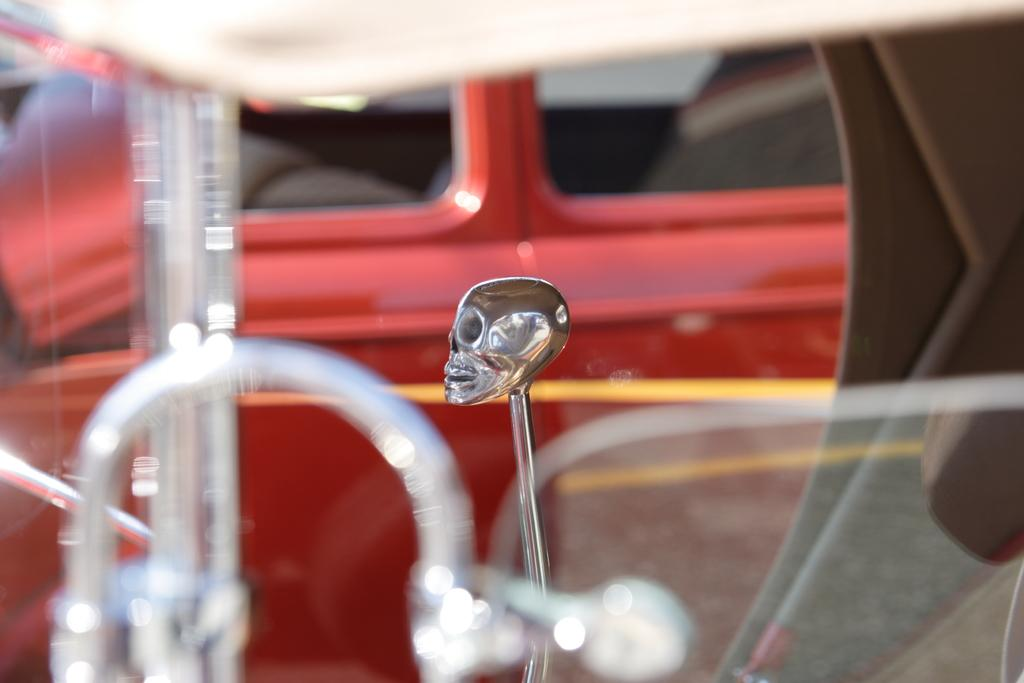What is the main subject of the image? The main subject of the image is a sculpture. How is the sculpture positioned in the image? The sculpture is on a stand. What else can be seen in the image besides the sculpture? There is a red color vehicle in the image. What type of acoustics can be heard coming from the sculpture in the image? The sculpture is not producing any sound, so there are no acoustics to be heard. Are there any giants present in the image? There are no giants depicted in the image; it features a sculpture and a red color vehicle. 